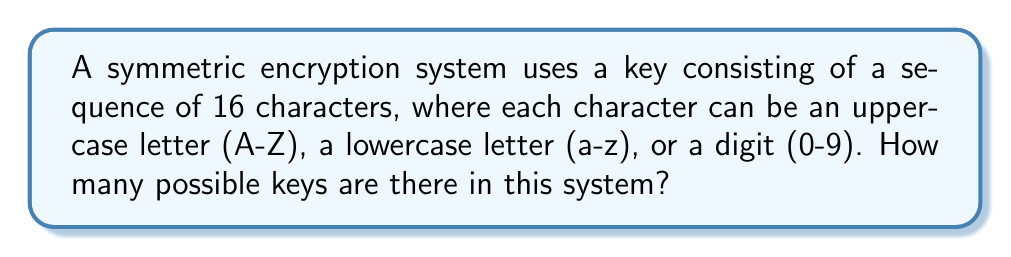Give your solution to this math problem. Let's approach this step-by-step:

1) First, we need to count the number of possible characters for each position in the key:
   - 26 uppercase letters (A-Z)
   - 26 lowercase letters (a-z)
   - 10 digits (0-9)

   Total: $26 + 26 + 10 = 62$ possible characters

2) Now, for each of the 16 positions in the key, we have 62 choices.

3) According to the fundamental counting principle, if we have a sequence of choices where:
   - we have $n_1$ ways of making the first choice,
   - $n_2$ ways of making the second choice,
   - and so on up to $n_k$ ways of making the $k$-th choice,

   Then the total number of ways to make all these choices is:

   $$ n_1 \times n_2 \times ... \times n_k $$

4) In our case, we have 62 choices for each of the 16 positions. So we have:

   $$ 62 \times 62 \times ... \times 62 \quad \text{(16 times)} $$

5) This can be written more concisely as:

   $$ 62^{16} $$

6) Calculating this:
   $$ 62^{16} = 4.7672401706823e28 \approx 4.77 \times 10^{28} $$

Therefore, there are approximately $4.77 \times 10^{28}$ possible keys in this symmetric encryption system.
Answer: $62^{16}$ or $\approx 4.77 \times 10^{28}$ 